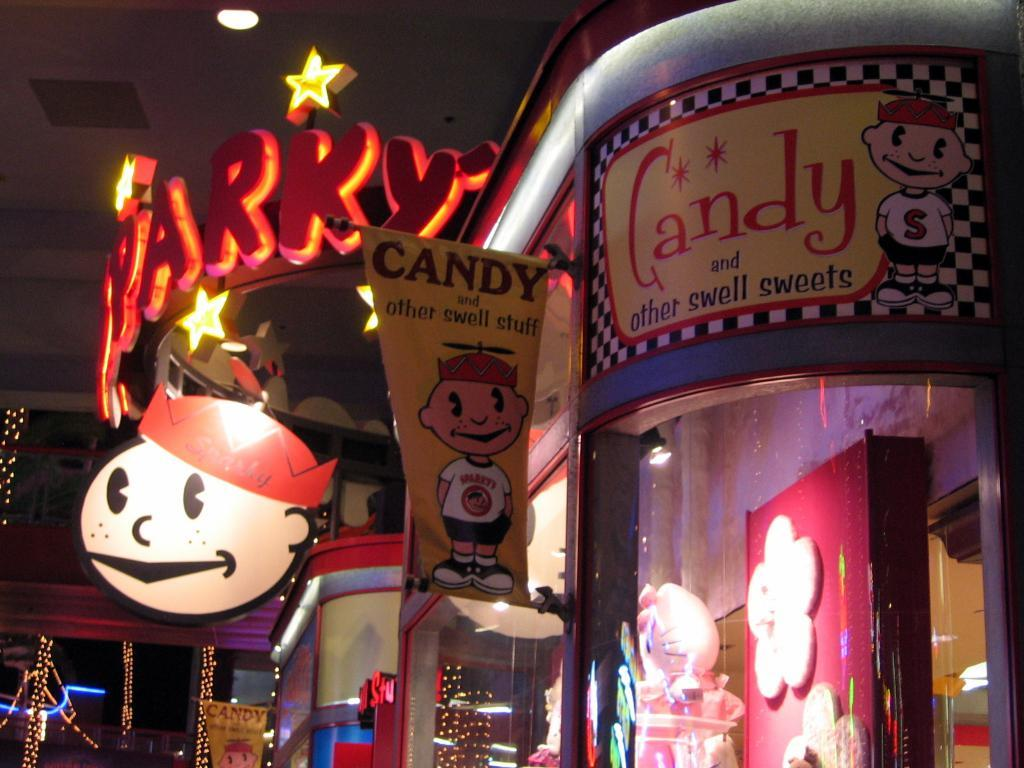What is attached to the wall in the image? There is a banner attached to the wall in the image. What can be seen on the left side of the image? There are lights on poles on the left side of the image. Can you describe the lighting in the room? There is a light on the ceiling in the image. What type of reward is hanging from the moon in the image? There is no moon or reward present in the image. How many copies of the banner are visible in the image? There is only one banner visible in the image. 